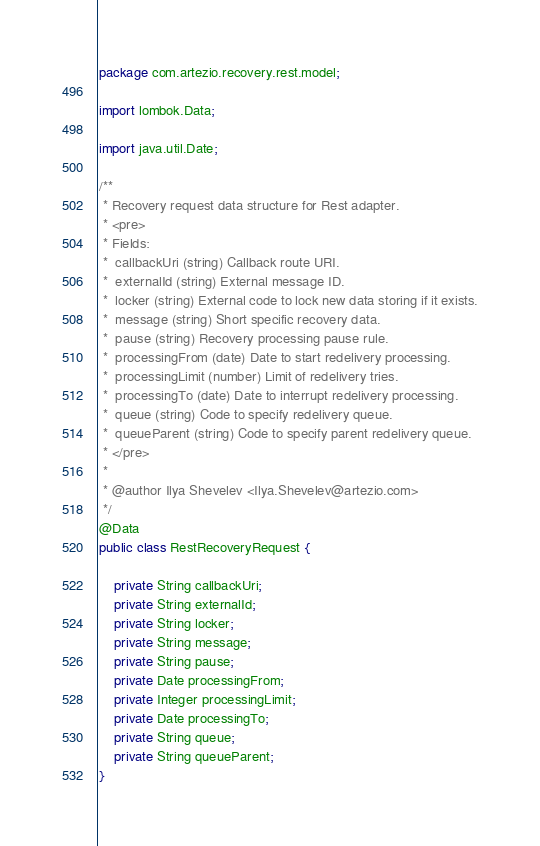Convert code to text. <code><loc_0><loc_0><loc_500><loc_500><_Java_>package com.artezio.recovery.rest.model;

import lombok.Data;

import java.util.Date;

/**
 * Recovery request data structure for Rest adapter.
 * <pre>
 * Fields:
 *  callbackUri (string) Callback route URI.
 *  externalId (string) External message ID.
 *  locker (string) External code to lock new data storing if it exists.
 *  message (string) Short specific recovery data.
 *  pause (string) Recovery processing pause rule.
 *  processingFrom (date) Date to start redelivery processing.
 *  processingLimit (number) Limit of redelivery tries.
 *  processingTo (date) Date to interrupt redelivery processing.
 *  queue (string) Code to specify redelivery queue.
 *  queueParent (string) Code to specify parent redelivery queue.
 * </pre>
 *
 * @author Ilya Shevelev <Ilya.Shevelev@artezio.com>
 */
@Data
public class RestRecoveryRequest {

    private String callbackUri;
    private String externalId;
    private String locker;
    private String message;
    private String pause;
    private Date processingFrom;
    private Integer processingLimit;
    private Date processingTo;
    private String queue;
    private String queueParent;
}
</code> 